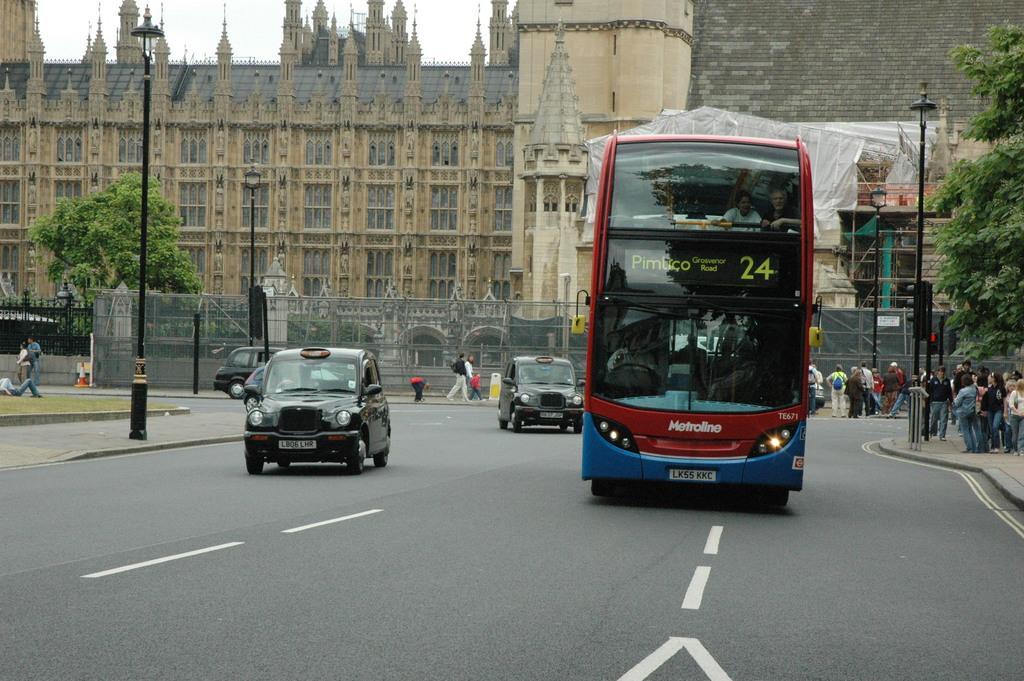In one or two sentences, can you explain what this image depicts? In this picture we can see a bus moving on the road. Beside there are some black cars. Behind there is a brown building. On the top we can see the sky. 